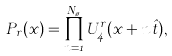<formula> <loc_0><loc_0><loc_500><loc_500>P _ { r } ( x ) = \prod _ { n = 1 } ^ { N _ { \tau } } U ^ { r } _ { 4 } ( x + n \hat { t } ) ,</formula> 